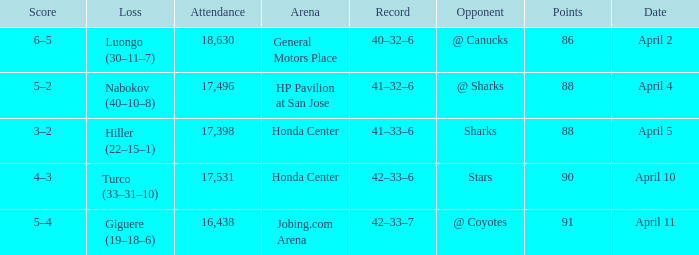How many Points have a Score of 3–2, and an Attendance larger than 17,398? None. 